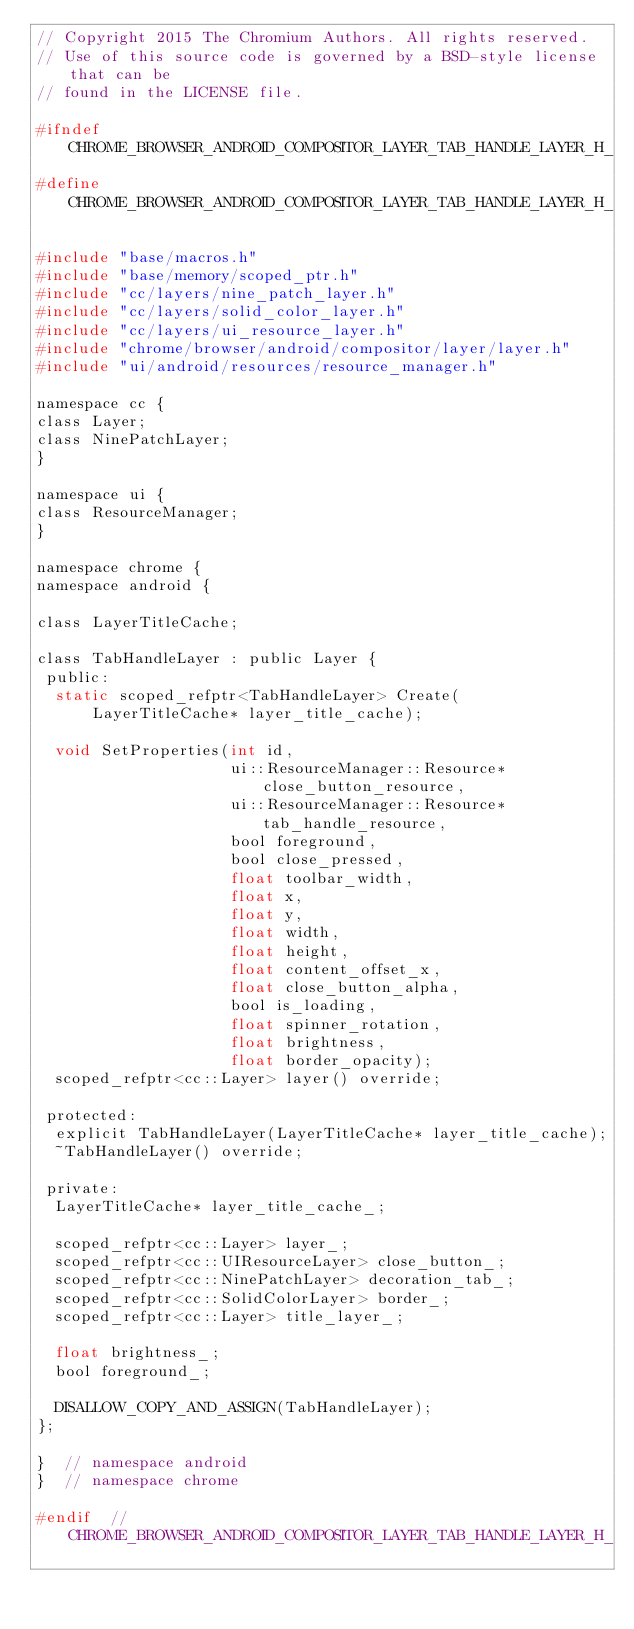Convert code to text. <code><loc_0><loc_0><loc_500><loc_500><_C_>// Copyright 2015 The Chromium Authors. All rights reserved.
// Use of this source code is governed by a BSD-style license that can be
// found in the LICENSE file.

#ifndef CHROME_BROWSER_ANDROID_COMPOSITOR_LAYER_TAB_HANDLE_LAYER_H_
#define CHROME_BROWSER_ANDROID_COMPOSITOR_LAYER_TAB_HANDLE_LAYER_H_

#include "base/macros.h"
#include "base/memory/scoped_ptr.h"
#include "cc/layers/nine_patch_layer.h"
#include "cc/layers/solid_color_layer.h"
#include "cc/layers/ui_resource_layer.h"
#include "chrome/browser/android/compositor/layer/layer.h"
#include "ui/android/resources/resource_manager.h"

namespace cc {
class Layer;
class NinePatchLayer;
}

namespace ui {
class ResourceManager;
}

namespace chrome {
namespace android {

class LayerTitleCache;

class TabHandleLayer : public Layer {
 public:
  static scoped_refptr<TabHandleLayer> Create(
      LayerTitleCache* layer_title_cache);

  void SetProperties(int id,
                     ui::ResourceManager::Resource* close_button_resource,
                     ui::ResourceManager::Resource* tab_handle_resource,
                     bool foreground,
                     bool close_pressed,
                     float toolbar_width,
                     float x,
                     float y,
                     float width,
                     float height,
                     float content_offset_x,
                     float close_button_alpha,
                     bool is_loading,
                     float spinner_rotation,
                     float brightness,
                     float border_opacity);
  scoped_refptr<cc::Layer> layer() override;

 protected:
  explicit TabHandleLayer(LayerTitleCache* layer_title_cache);
  ~TabHandleLayer() override;

 private:
  LayerTitleCache* layer_title_cache_;

  scoped_refptr<cc::Layer> layer_;
  scoped_refptr<cc::UIResourceLayer> close_button_;
  scoped_refptr<cc::NinePatchLayer> decoration_tab_;
  scoped_refptr<cc::SolidColorLayer> border_;
  scoped_refptr<cc::Layer> title_layer_;

  float brightness_;
  bool foreground_;

  DISALLOW_COPY_AND_ASSIGN(TabHandleLayer);
};

}  // namespace android
}  // namespace chrome

#endif  // CHROME_BROWSER_ANDROID_COMPOSITOR_LAYER_TAB_HANDLE_LAYER_H_
</code> 